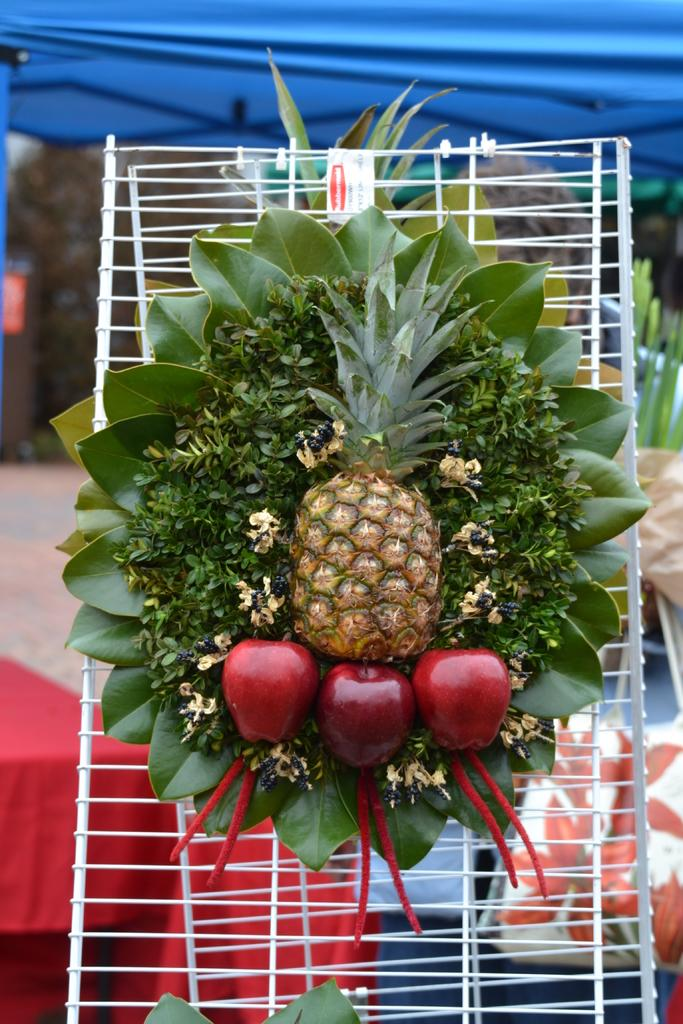What type of food can be seen in the image? There are fruits in the image. What else is present in the image besides the fruits? There are leaves in the image, and they are on a fencing. What can be seen in the background of the image? There is a tent visible in the background of the image. Is there anyone near the tent? Yes, a person is standing near the tent. What type of hair can be seen on the person standing near the tent? There is no information about the person's hair in the image, so it cannot be determined. 